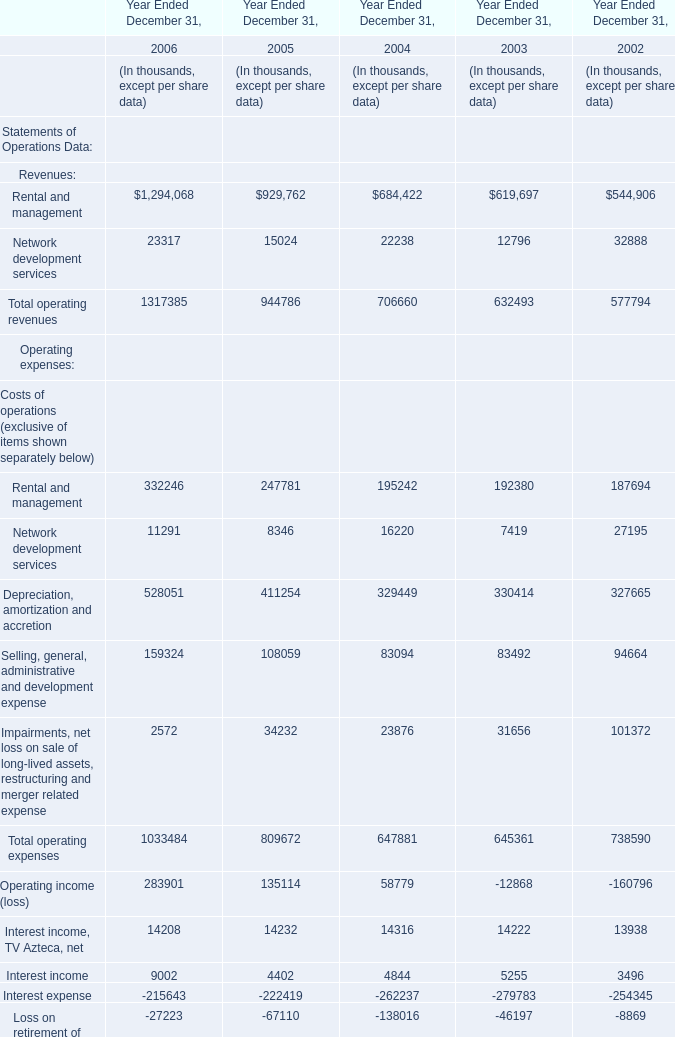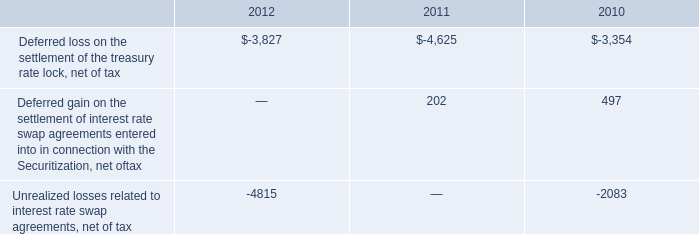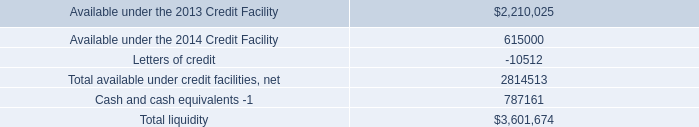If operating expenses develops with the same increasing rate in 2006, what will it reach in 2007? (in thousand) 
Computations: (exp((1 + ((1033484 - 809672) / 809672)) * 2))
Answer: 1683809.79168. 